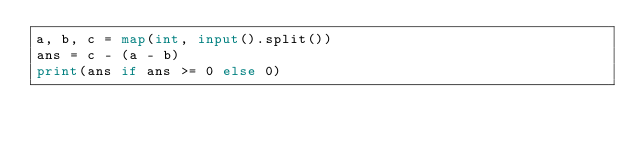<code> <loc_0><loc_0><loc_500><loc_500><_Python_>a, b, c = map(int, input().split())
ans = c - (a - b)
print(ans if ans >= 0 else 0)
</code> 